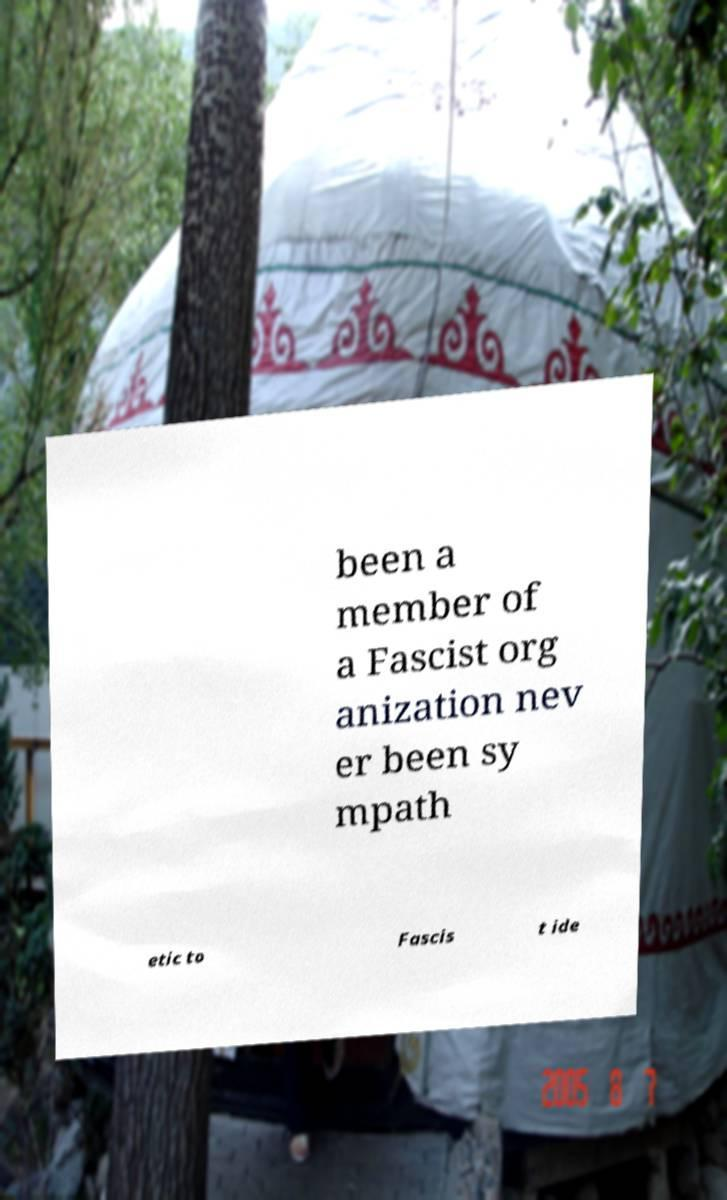There's text embedded in this image that I need extracted. Can you transcribe it verbatim? been a member of a Fascist org anization nev er been sy mpath etic to Fascis t ide 